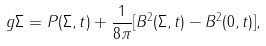<formula> <loc_0><loc_0><loc_500><loc_500>g \Sigma = P ( \Sigma , t ) + \frac { 1 } { 8 \pi } [ B ^ { 2 } ( \Sigma , t ) - B ^ { 2 } ( 0 , t ) ] ,</formula> 